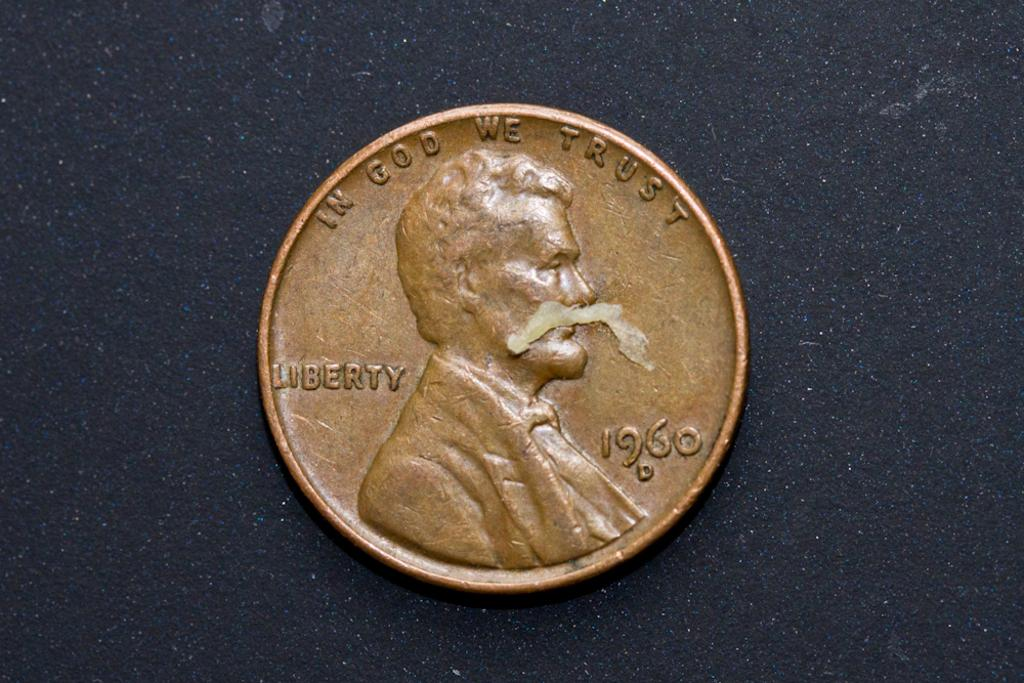<image>
Provide a brief description of the given image. A 1960 bronze coin with a text saying In God we trust. 